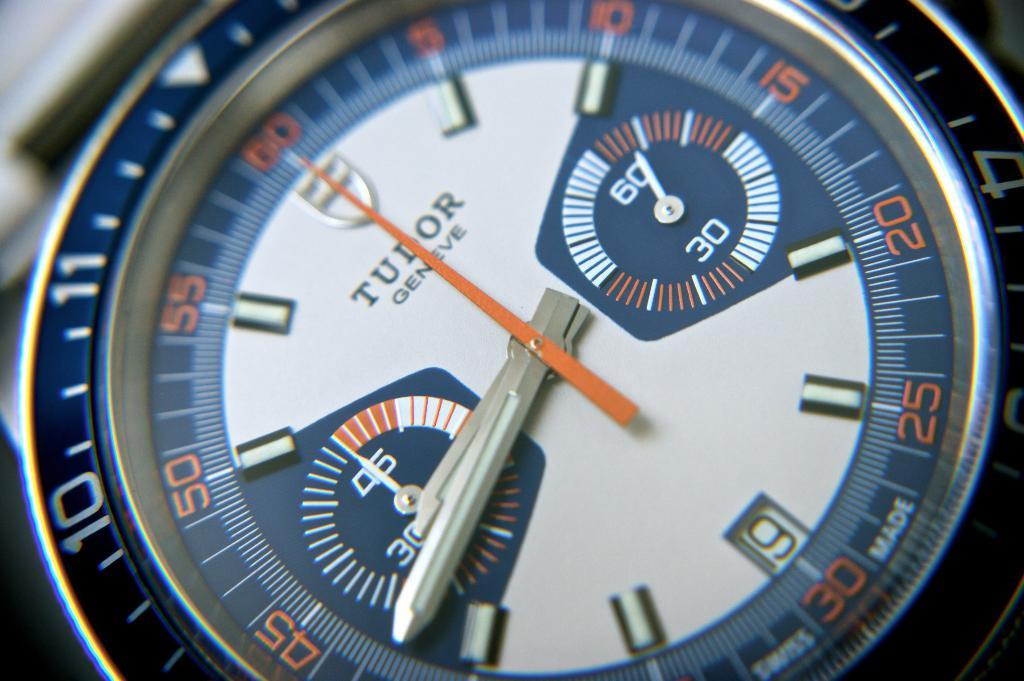What number is the second hand pointing to?
Offer a very short reply. 60. What brand of watch is this?
Your answer should be compact. Tudor. 